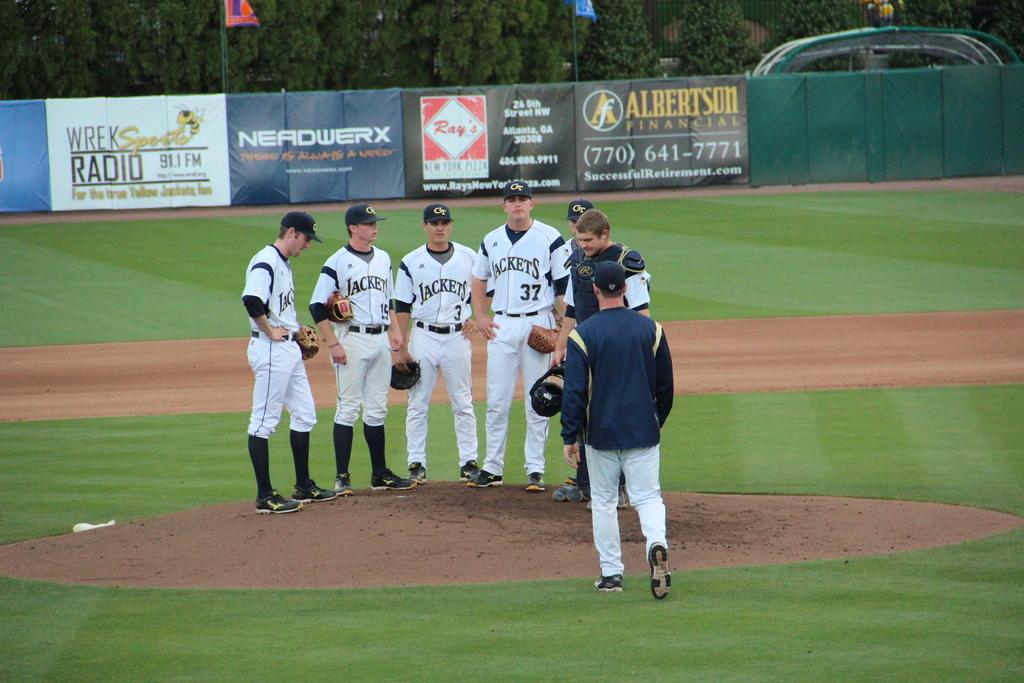<image>
Create a compact narrative representing the image presented. Players from the Jackets baseball team are standing on the pitcher's mound. 